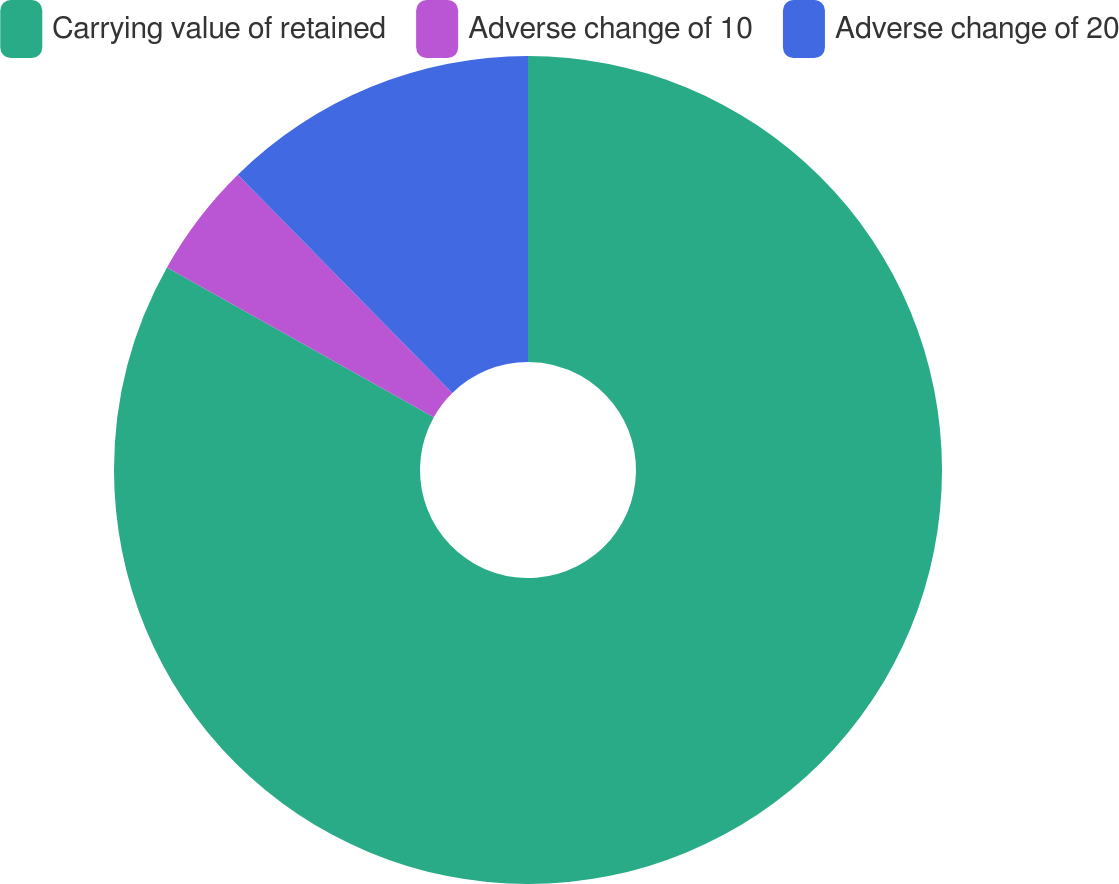Convert chart to OTSL. <chart><loc_0><loc_0><loc_500><loc_500><pie_chart><fcel>Carrying value of retained<fcel>Adverse change of 10<fcel>Adverse change of 20<nl><fcel>83.13%<fcel>4.5%<fcel>12.36%<nl></chart> 